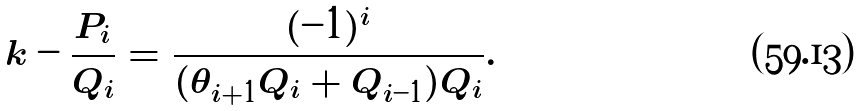<formula> <loc_0><loc_0><loc_500><loc_500>k - \frac { P _ { i } } { Q _ { i } } = \frac { ( - 1 ) ^ { i } } { ( \theta _ { i + 1 } Q _ { i } + Q _ { i - 1 } ) Q _ { i } } .</formula> 